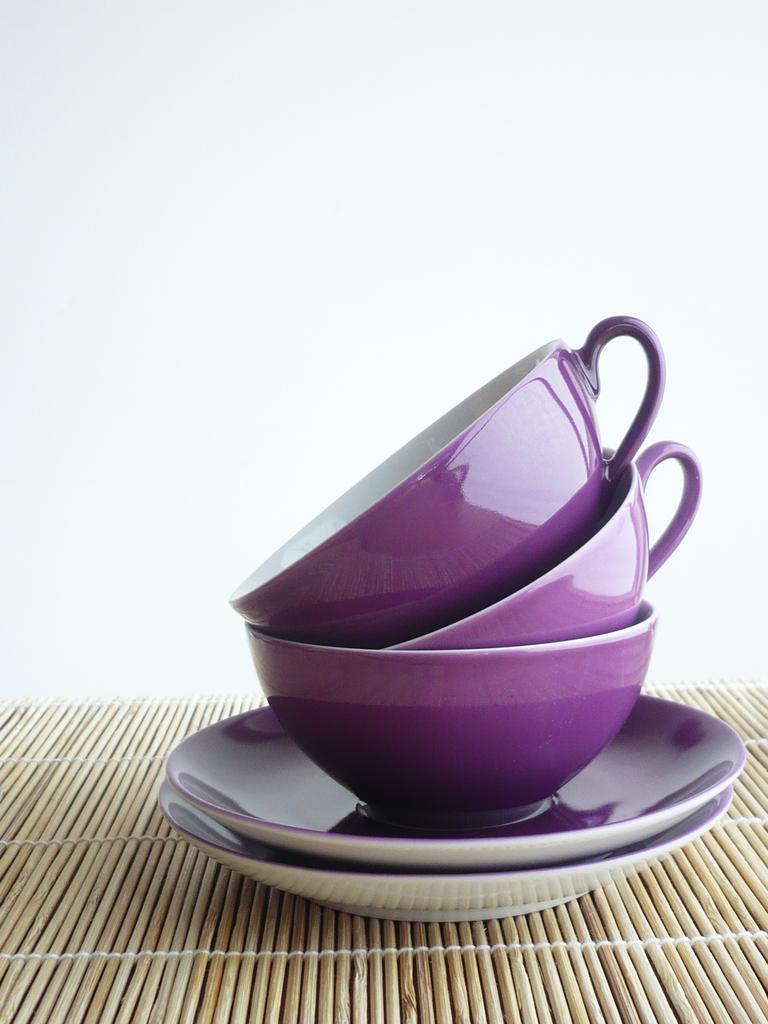Can you describe this image briefly? In this image I can see purple cups and saucers. There is a white background. 